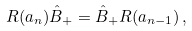<formula> <loc_0><loc_0><loc_500><loc_500>R ( a _ { n } ) \hat { B } _ { + } = \hat { B } _ { + } R ( a _ { n - 1 } ) \, ,</formula> 